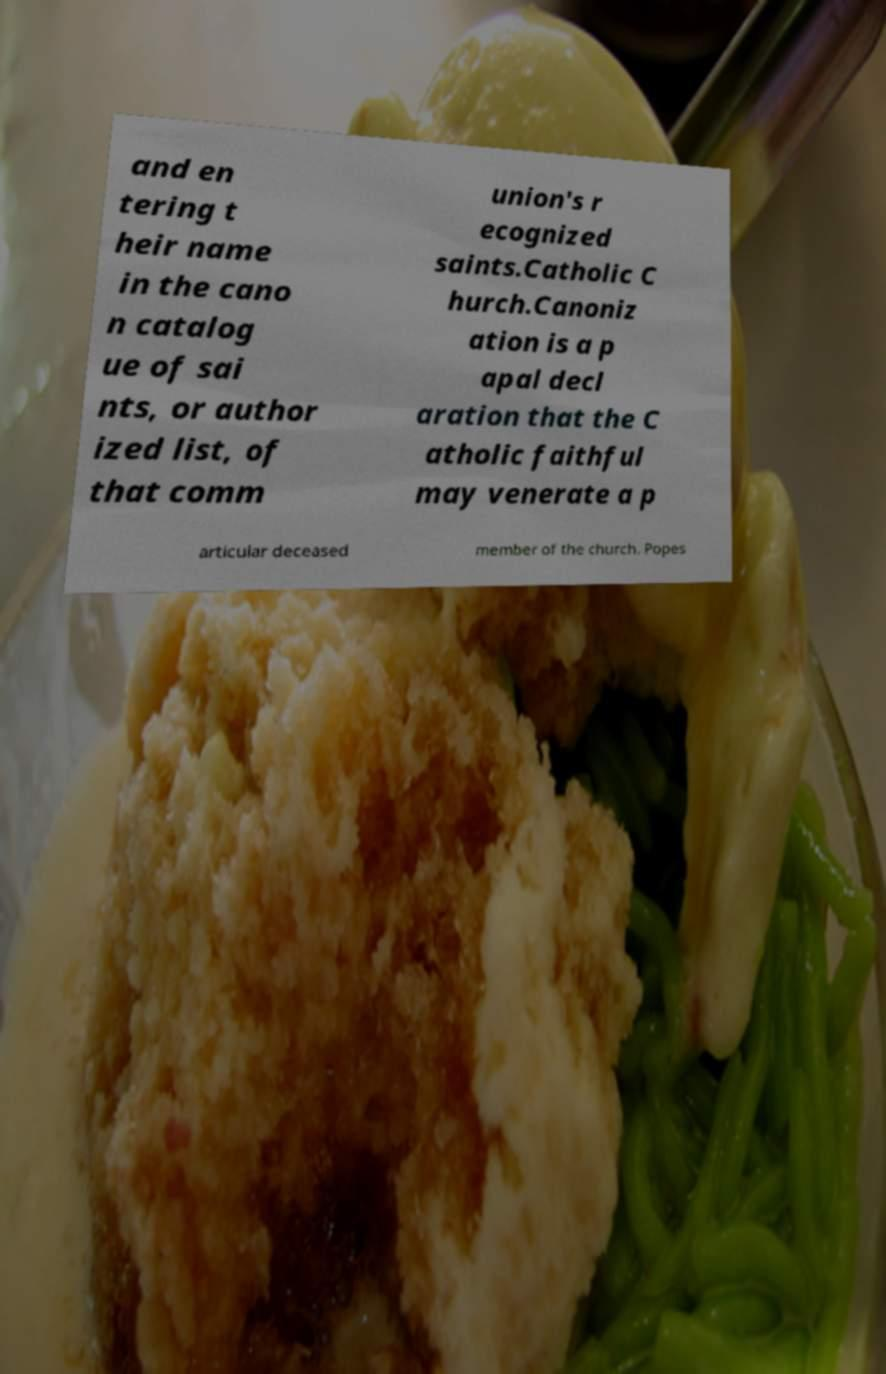Please read and relay the text visible in this image. What does it say? and en tering t heir name in the cano n catalog ue of sai nts, or author ized list, of that comm union's r ecognized saints.Catholic C hurch.Canoniz ation is a p apal decl aration that the C atholic faithful may venerate a p articular deceased member of the church. Popes 